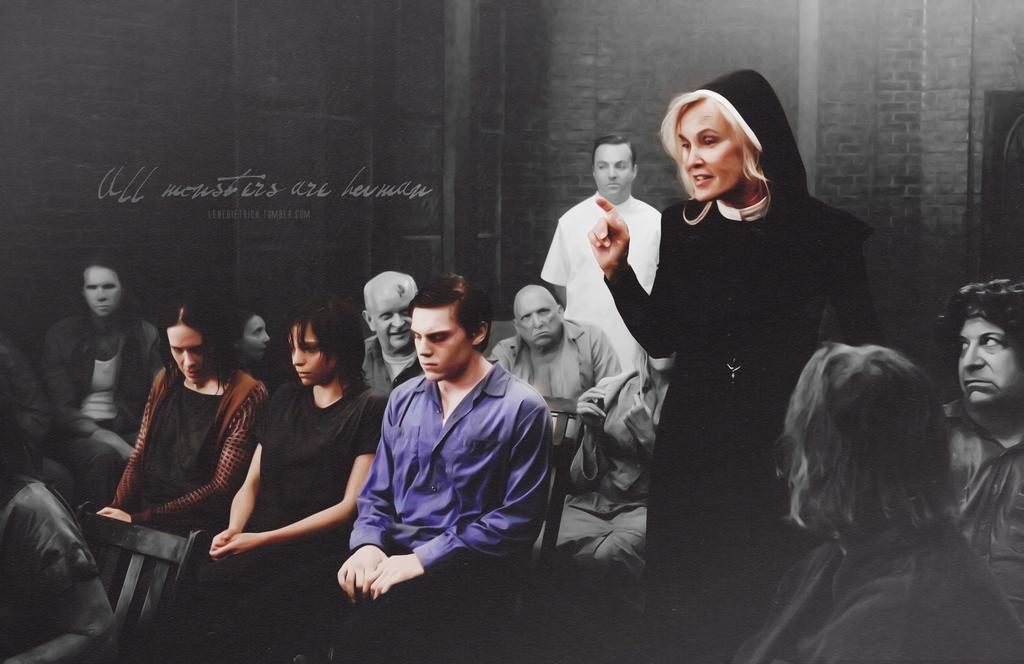What is the primary action of the woman in the image? The woman is standing in the image. What are the other people in the image doing? Other people are sitting in the image. Can you describe the person standing at the back? The person standing at the back is wearing a white shirt. What is located at the back of the image? There is a wall at the back in the image. What type of shame is the woman feeling in the image? There is no indication of shame in the image; the woman is simply standing. How many stitches are visible on the shirt of the person standing at the back? There is no mention of stitches on the shirt of the person standing at the back, and the image does not provide enough detail to count stitches. 